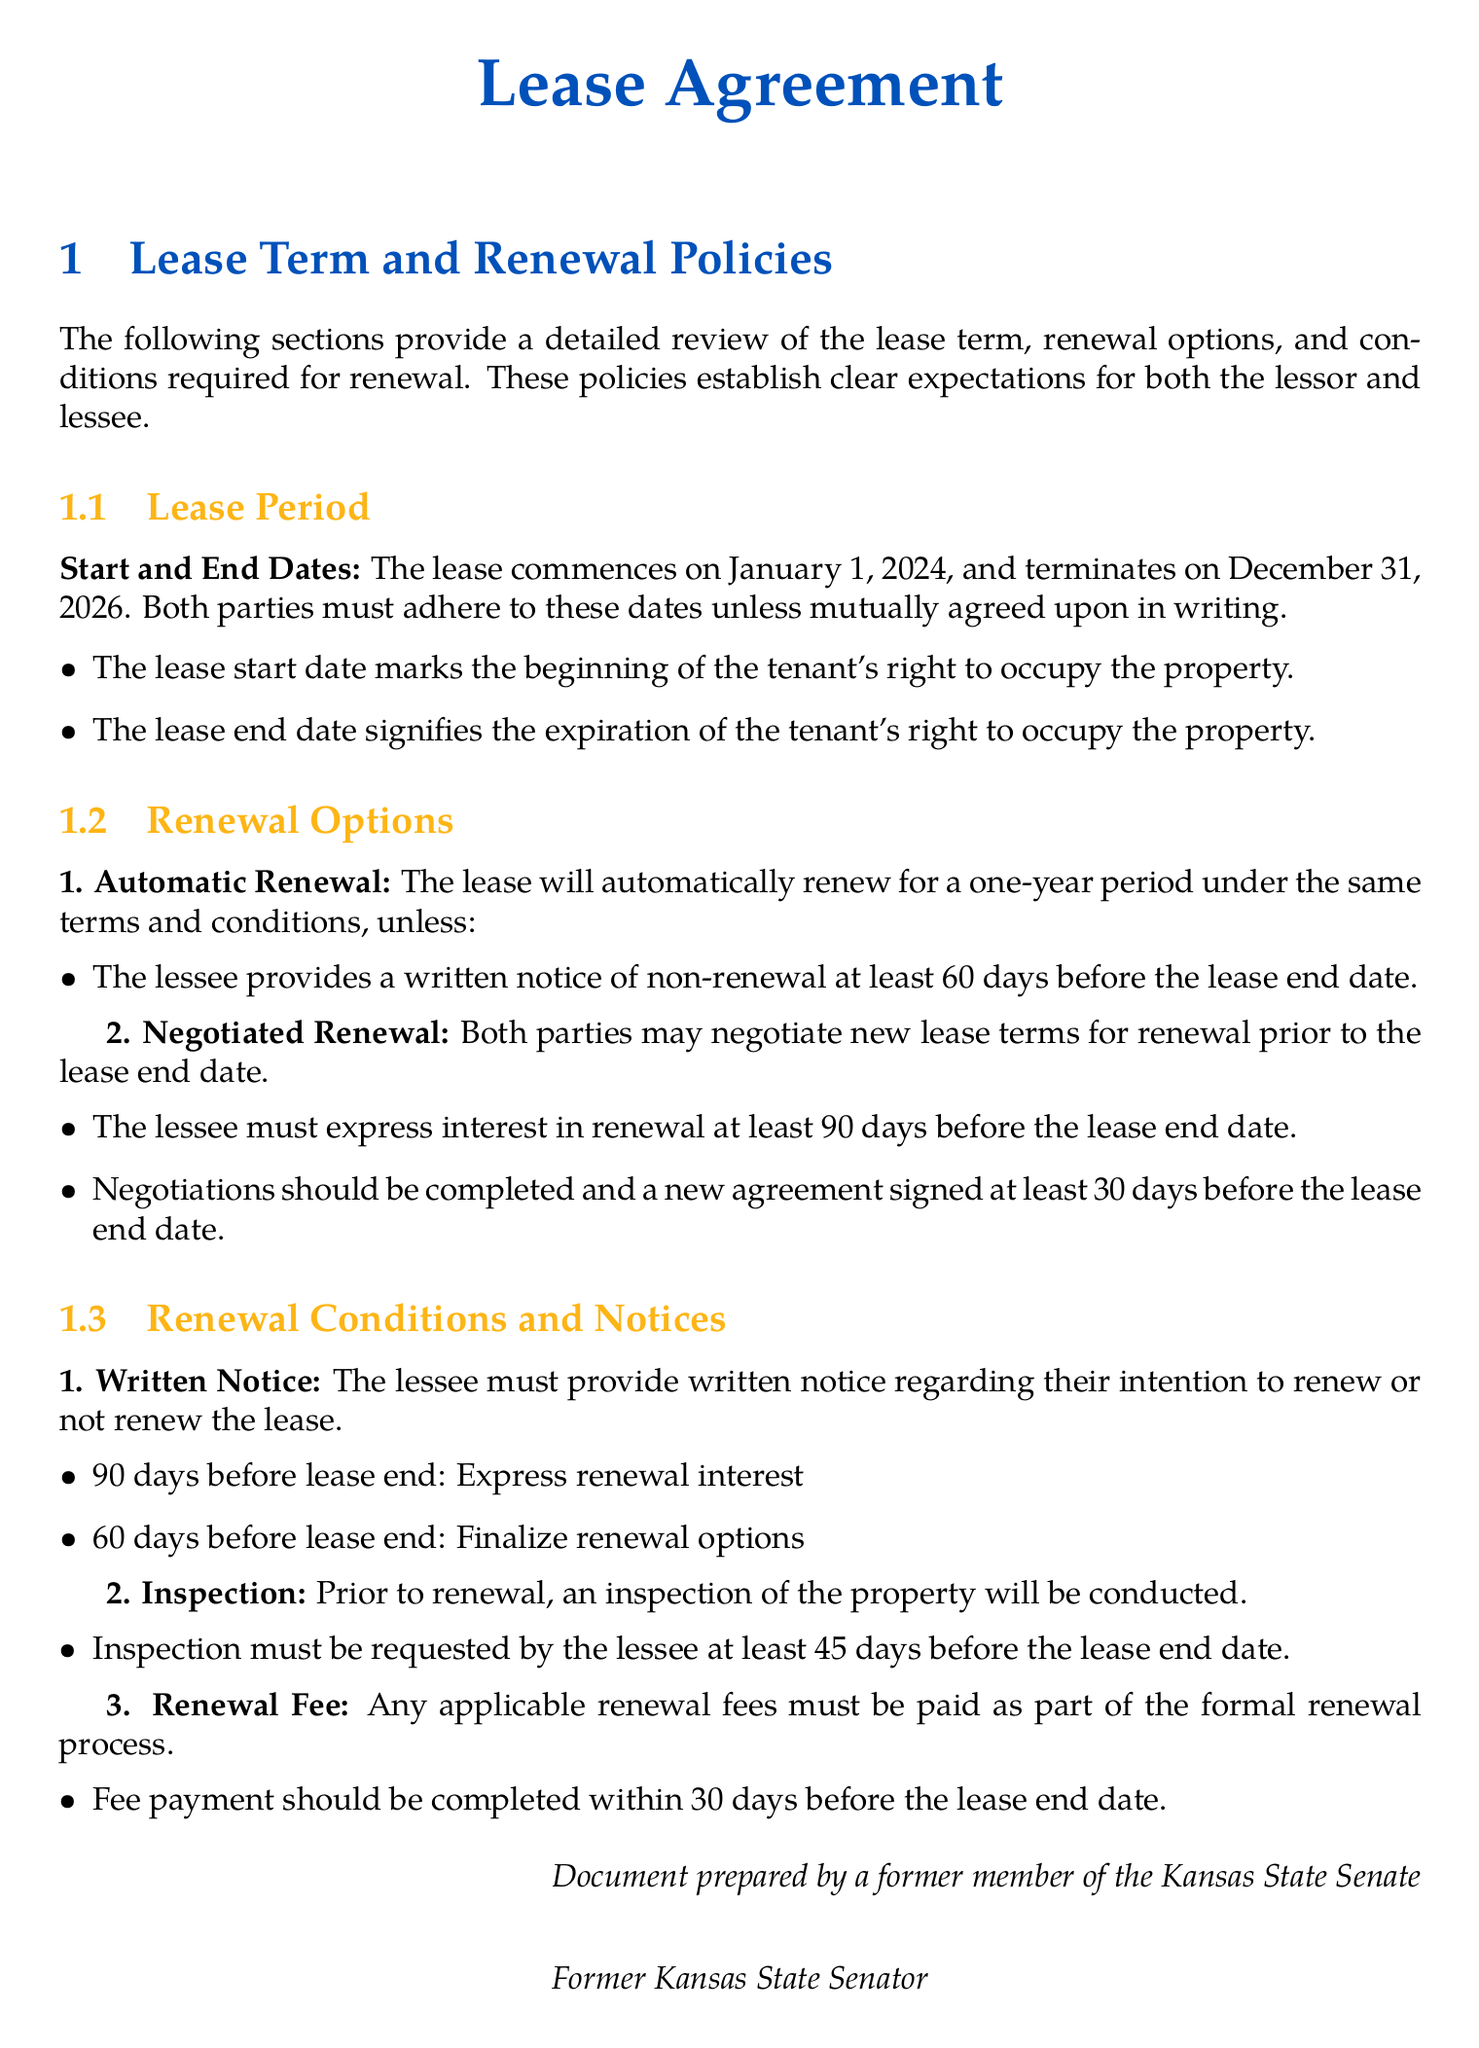What are the lease start and end dates? The lease details the commencement and termination dates of the lease period, which are January 1, 2024, to December 31, 2026.
Answer: January 1, 2024, to December 31, 2026 What is the notice period for non-renewal? The document states the required notice timeframe for the lessee to decline the renewal of the lease.
Answer: 60 days When should the lessee express interest in renewal? The lease provides specific timing for the lessee to indicate whether they wish to renew, which is 90 days before ending.
Answer: 90 days What is required before a lease renewal? The document states an inspection prerequisite prior to renewal along with notification details.
Answer: Inspection What is the renewal fee payment deadline? This is specified in the renewal conditions section, indicating a timeline for renewal fees to be completed.
Answer: 30 days What is the automatic renewal period? The lease specifies how long the lease will automatically extend if not otherwise noted by either party.
Answer: One-year What must be finalized at least 30 days before the lease end date? The document indicates that negotiations for renewal must reach completion by this timeframe prior to lease expiration.
Answer: New agreement When can the lessee request an inspection? The document outlines a specific timeframe for the lessee to submit an inspection request before lease expiration.
Answer: 45 days 